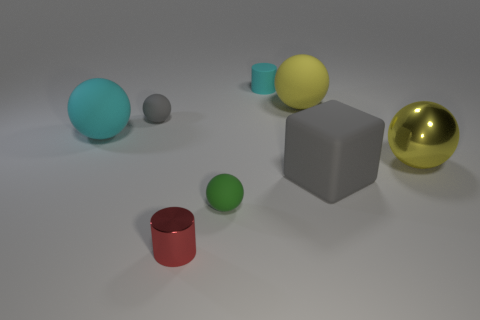There is a yellow thing behind the gray rubber ball; is there a tiny ball that is to the left of it?
Offer a terse response. Yes. How many blocks are either tiny green matte things or large yellow objects?
Provide a succinct answer. 0. Is there a cyan matte thing that has the same shape as the green rubber thing?
Keep it short and to the point. Yes. What is the shape of the small green thing?
Offer a very short reply. Sphere. How many objects are small red metal objects or big gray matte things?
Make the answer very short. 2. Do the matte object in front of the large cube and the matte object that is to the left of the small gray rubber object have the same size?
Your answer should be very brief. No. What number of other objects are the same material as the big cube?
Your response must be concise. 5. Are there more tiny matte balls that are in front of the shiny ball than big cyan spheres right of the large gray rubber cube?
Keep it short and to the point. Yes. What is the large yellow ball that is behind the large cyan matte ball made of?
Provide a succinct answer. Rubber. Is the big yellow rubber thing the same shape as the large gray rubber object?
Give a very brief answer. No. 